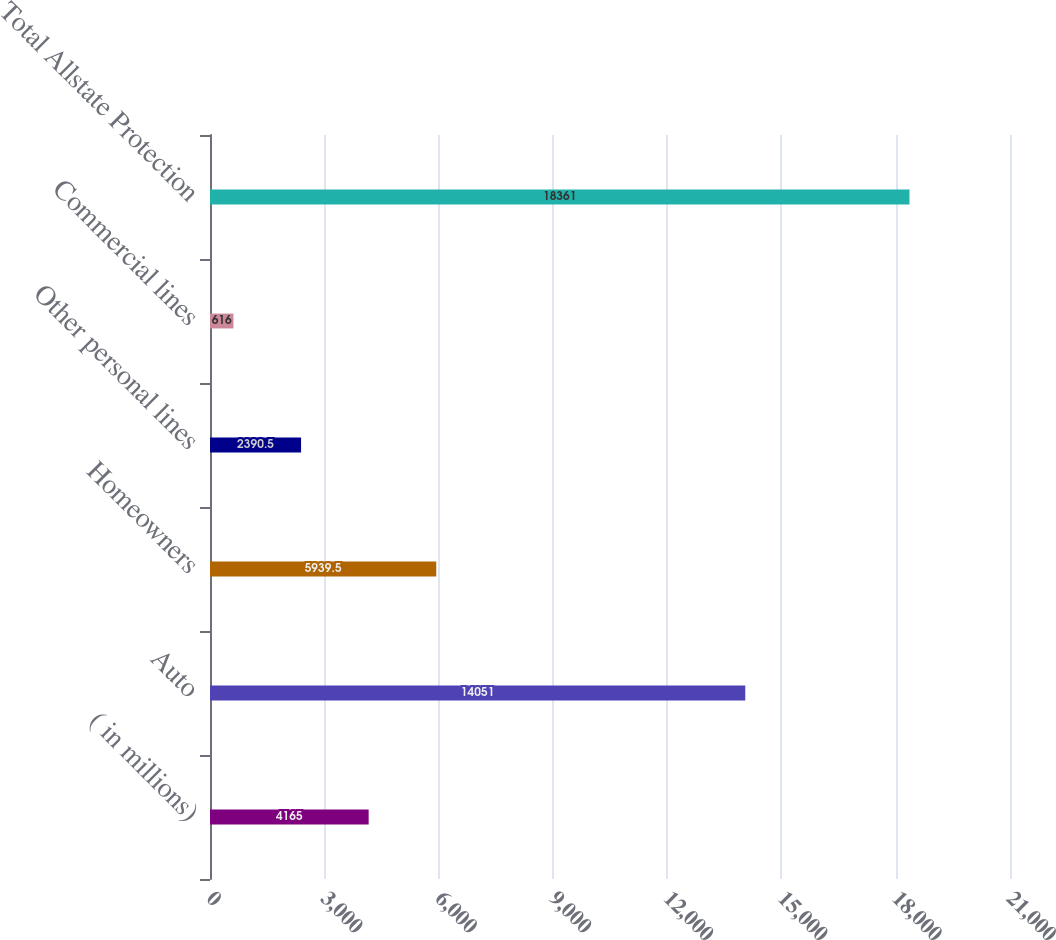Convert chart to OTSL. <chart><loc_0><loc_0><loc_500><loc_500><bar_chart><fcel>( in millions)<fcel>Auto<fcel>Homeowners<fcel>Other personal lines<fcel>Commercial lines<fcel>Total Allstate Protection<nl><fcel>4165<fcel>14051<fcel>5939.5<fcel>2390.5<fcel>616<fcel>18361<nl></chart> 